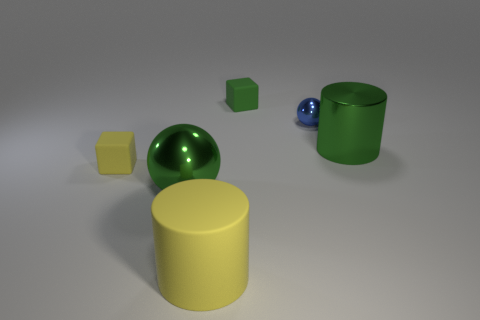The big thing that is made of the same material as the tiny green object is what shape? cylinder 